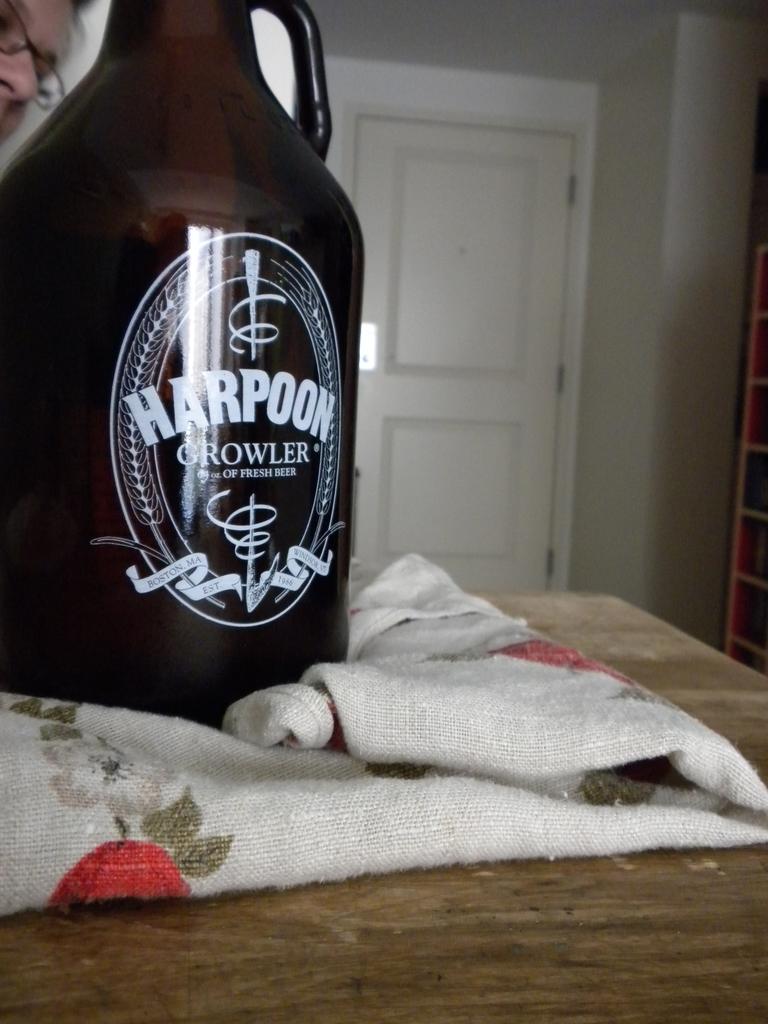Who make this growler?
Provide a succinct answer. Harpoon. 